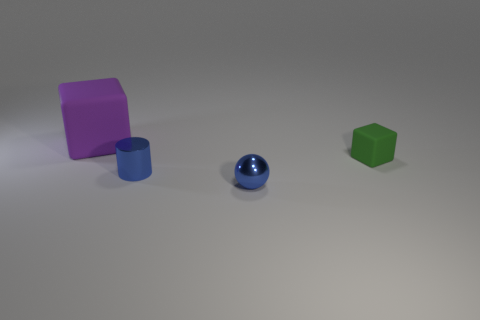How would you describe the lighting and shadow effects in the scene? The scene is lit from above, casting soft shadows underneath each object. The shadows are soft-edged, indicating a diffused light source, and contribute to the sense of depth and dimension in the image. 